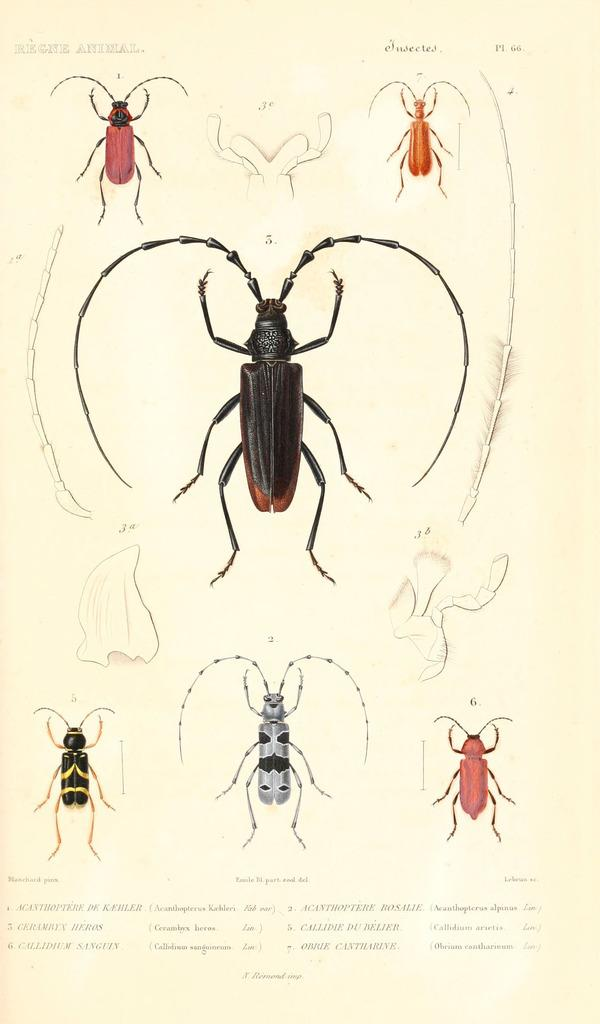What is featured in the image that is not text? There is a poster in the image that has images on it. What type of images are on the poster? The images on the poster are of insects. Where is the text located on the poster? The text is located at the bottom of the image. How are the dogs being sorted in the image? There are no dogs present in the image; it features a poster with images of insects and text. 